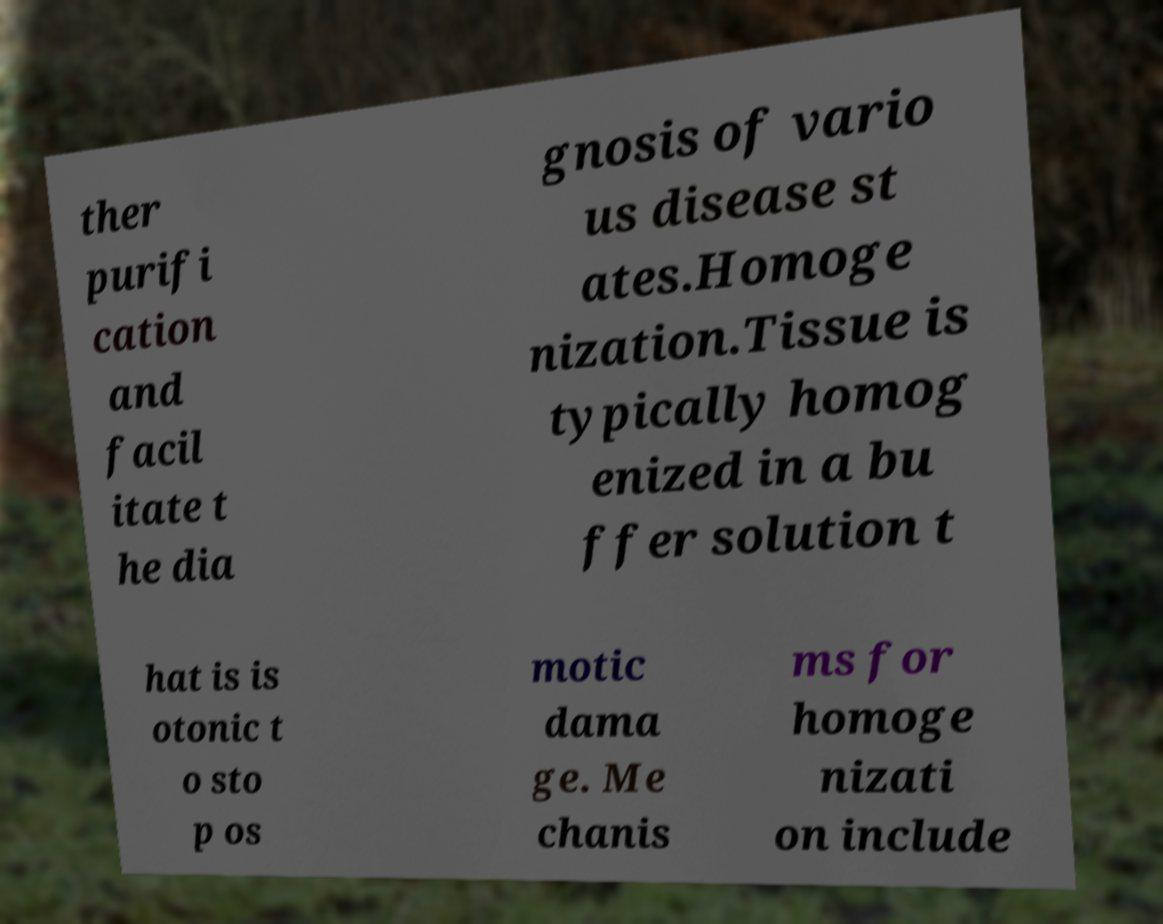Could you assist in decoding the text presented in this image and type it out clearly? ther purifi cation and facil itate t he dia gnosis of vario us disease st ates.Homoge nization.Tissue is typically homog enized in a bu ffer solution t hat is is otonic t o sto p os motic dama ge. Me chanis ms for homoge nizati on include 